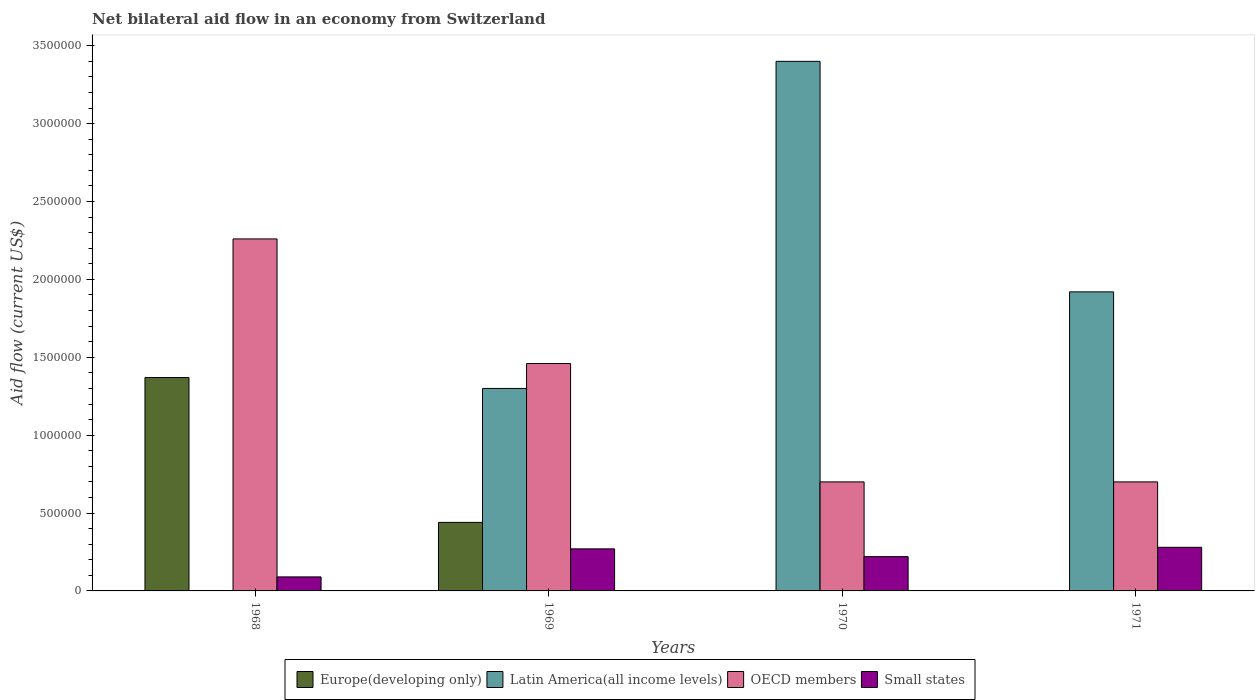How many bars are there on the 4th tick from the left?
Make the answer very short. 3. How many bars are there on the 3rd tick from the right?
Ensure brevity in your answer.  4. Across all years, what is the maximum net bilateral aid flow in Small states?
Your answer should be compact. 2.80e+05. In which year was the net bilateral aid flow in Europe(developing only) maximum?
Provide a succinct answer. 1968. What is the total net bilateral aid flow in Small states in the graph?
Your answer should be very brief. 8.60e+05. What is the difference between the net bilateral aid flow in Small states in 1969 and that in 1970?
Give a very brief answer. 5.00e+04. What is the difference between the net bilateral aid flow in OECD members in 1968 and the net bilateral aid flow in Small states in 1969?
Your answer should be compact. 1.99e+06. What is the average net bilateral aid flow in Latin America(all income levels) per year?
Your answer should be very brief. 1.66e+06. In the year 1970, what is the difference between the net bilateral aid flow in Latin America(all income levels) and net bilateral aid flow in Small states?
Offer a very short reply. 3.18e+06. What is the ratio of the net bilateral aid flow in Small states in 1968 to that in 1969?
Keep it short and to the point. 0.33. Is the difference between the net bilateral aid flow in Latin America(all income levels) in 1969 and 1971 greater than the difference between the net bilateral aid flow in Small states in 1969 and 1971?
Ensure brevity in your answer.  No. What is the difference between the highest and the second highest net bilateral aid flow in Latin America(all income levels)?
Your response must be concise. 1.48e+06. What is the difference between the highest and the lowest net bilateral aid flow in OECD members?
Your answer should be compact. 1.56e+06. Is the sum of the net bilateral aid flow in Small states in 1968 and 1969 greater than the maximum net bilateral aid flow in Europe(developing only) across all years?
Offer a very short reply. No. Is it the case that in every year, the sum of the net bilateral aid flow in OECD members and net bilateral aid flow in Latin America(all income levels) is greater than the sum of net bilateral aid flow in Small states and net bilateral aid flow in Europe(developing only)?
Make the answer very short. Yes. Is it the case that in every year, the sum of the net bilateral aid flow in Latin America(all income levels) and net bilateral aid flow in OECD members is greater than the net bilateral aid flow in Europe(developing only)?
Your response must be concise. Yes. How many years are there in the graph?
Your answer should be compact. 4. What is the difference between two consecutive major ticks on the Y-axis?
Your answer should be compact. 5.00e+05. Are the values on the major ticks of Y-axis written in scientific E-notation?
Your answer should be very brief. No. Does the graph contain any zero values?
Offer a terse response. Yes. Where does the legend appear in the graph?
Give a very brief answer. Bottom center. What is the title of the graph?
Keep it short and to the point. Net bilateral aid flow in an economy from Switzerland. Does "Upper middle income" appear as one of the legend labels in the graph?
Ensure brevity in your answer.  No. What is the label or title of the X-axis?
Offer a terse response. Years. What is the label or title of the Y-axis?
Your answer should be very brief. Aid flow (current US$). What is the Aid flow (current US$) of Europe(developing only) in 1968?
Your response must be concise. 1.37e+06. What is the Aid flow (current US$) in OECD members in 1968?
Your answer should be compact. 2.26e+06. What is the Aid flow (current US$) of Europe(developing only) in 1969?
Give a very brief answer. 4.40e+05. What is the Aid flow (current US$) of Latin America(all income levels) in 1969?
Make the answer very short. 1.30e+06. What is the Aid flow (current US$) of OECD members in 1969?
Your response must be concise. 1.46e+06. What is the Aid flow (current US$) of Europe(developing only) in 1970?
Provide a succinct answer. 0. What is the Aid flow (current US$) in Latin America(all income levels) in 1970?
Give a very brief answer. 3.40e+06. What is the Aid flow (current US$) in Small states in 1970?
Offer a very short reply. 2.20e+05. What is the Aid flow (current US$) of Latin America(all income levels) in 1971?
Your answer should be very brief. 1.92e+06. What is the Aid flow (current US$) in OECD members in 1971?
Give a very brief answer. 7.00e+05. Across all years, what is the maximum Aid flow (current US$) in Europe(developing only)?
Make the answer very short. 1.37e+06. Across all years, what is the maximum Aid flow (current US$) in Latin America(all income levels)?
Offer a very short reply. 3.40e+06. Across all years, what is the maximum Aid flow (current US$) in OECD members?
Make the answer very short. 2.26e+06. Across all years, what is the minimum Aid flow (current US$) of Latin America(all income levels)?
Your answer should be very brief. 0. Across all years, what is the minimum Aid flow (current US$) of Small states?
Your answer should be very brief. 9.00e+04. What is the total Aid flow (current US$) of Europe(developing only) in the graph?
Ensure brevity in your answer.  1.81e+06. What is the total Aid flow (current US$) in Latin America(all income levels) in the graph?
Your response must be concise. 6.62e+06. What is the total Aid flow (current US$) in OECD members in the graph?
Ensure brevity in your answer.  5.12e+06. What is the total Aid flow (current US$) in Small states in the graph?
Keep it short and to the point. 8.60e+05. What is the difference between the Aid flow (current US$) in Europe(developing only) in 1968 and that in 1969?
Provide a short and direct response. 9.30e+05. What is the difference between the Aid flow (current US$) of OECD members in 1968 and that in 1970?
Provide a short and direct response. 1.56e+06. What is the difference between the Aid flow (current US$) of OECD members in 1968 and that in 1971?
Keep it short and to the point. 1.56e+06. What is the difference between the Aid flow (current US$) of Latin America(all income levels) in 1969 and that in 1970?
Your answer should be compact. -2.10e+06. What is the difference between the Aid flow (current US$) of OECD members in 1969 and that in 1970?
Give a very brief answer. 7.60e+05. What is the difference between the Aid flow (current US$) of Latin America(all income levels) in 1969 and that in 1971?
Your answer should be very brief. -6.20e+05. What is the difference between the Aid flow (current US$) of OECD members in 1969 and that in 1971?
Offer a very short reply. 7.60e+05. What is the difference between the Aid flow (current US$) in Small states in 1969 and that in 1971?
Provide a succinct answer. -10000. What is the difference between the Aid flow (current US$) in Latin America(all income levels) in 1970 and that in 1971?
Provide a short and direct response. 1.48e+06. What is the difference between the Aid flow (current US$) of Europe(developing only) in 1968 and the Aid flow (current US$) of Latin America(all income levels) in 1969?
Offer a terse response. 7.00e+04. What is the difference between the Aid flow (current US$) in Europe(developing only) in 1968 and the Aid flow (current US$) in Small states in 1969?
Make the answer very short. 1.10e+06. What is the difference between the Aid flow (current US$) in OECD members in 1968 and the Aid flow (current US$) in Small states in 1969?
Keep it short and to the point. 1.99e+06. What is the difference between the Aid flow (current US$) in Europe(developing only) in 1968 and the Aid flow (current US$) in Latin America(all income levels) in 1970?
Your answer should be compact. -2.03e+06. What is the difference between the Aid flow (current US$) of Europe(developing only) in 1968 and the Aid flow (current US$) of OECD members in 1970?
Offer a very short reply. 6.70e+05. What is the difference between the Aid flow (current US$) of Europe(developing only) in 1968 and the Aid flow (current US$) of Small states in 1970?
Make the answer very short. 1.15e+06. What is the difference between the Aid flow (current US$) in OECD members in 1968 and the Aid flow (current US$) in Small states in 1970?
Provide a short and direct response. 2.04e+06. What is the difference between the Aid flow (current US$) in Europe(developing only) in 1968 and the Aid flow (current US$) in Latin America(all income levels) in 1971?
Offer a terse response. -5.50e+05. What is the difference between the Aid flow (current US$) of Europe(developing only) in 1968 and the Aid flow (current US$) of OECD members in 1971?
Provide a succinct answer. 6.70e+05. What is the difference between the Aid flow (current US$) of Europe(developing only) in 1968 and the Aid flow (current US$) of Small states in 1971?
Your response must be concise. 1.09e+06. What is the difference between the Aid flow (current US$) in OECD members in 1968 and the Aid flow (current US$) in Small states in 1971?
Ensure brevity in your answer.  1.98e+06. What is the difference between the Aid flow (current US$) in Europe(developing only) in 1969 and the Aid flow (current US$) in Latin America(all income levels) in 1970?
Keep it short and to the point. -2.96e+06. What is the difference between the Aid flow (current US$) of Europe(developing only) in 1969 and the Aid flow (current US$) of OECD members in 1970?
Your answer should be compact. -2.60e+05. What is the difference between the Aid flow (current US$) in Europe(developing only) in 1969 and the Aid flow (current US$) in Small states in 1970?
Offer a very short reply. 2.20e+05. What is the difference between the Aid flow (current US$) of Latin America(all income levels) in 1969 and the Aid flow (current US$) of OECD members in 1970?
Offer a very short reply. 6.00e+05. What is the difference between the Aid flow (current US$) in Latin America(all income levels) in 1969 and the Aid flow (current US$) in Small states in 1970?
Your response must be concise. 1.08e+06. What is the difference between the Aid flow (current US$) in OECD members in 1969 and the Aid flow (current US$) in Small states in 1970?
Keep it short and to the point. 1.24e+06. What is the difference between the Aid flow (current US$) in Europe(developing only) in 1969 and the Aid flow (current US$) in Latin America(all income levels) in 1971?
Your response must be concise. -1.48e+06. What is the difference between the Aid flow (current US$) in Europe(developing only) in 1969 and the Aid flow (current US$) in OECD members in 1971?
Ensure brevity in your answer.  -2.60e+05. What is the difference between the Aid flow (current US$) of Europe(developing only) in 1969 and the Aid flow (current US$) of Small states in 1971?
Your answer should be very brief. 1.60e+05. What is the difference between the Aid flow (current US$) in Latin America(all income levels) in 1969 and the Aid flow (current US$) in Small states in 1971?
Make the answer very short. 1.02e+06. What is the difference between the Aid flow (current US$) of OECD members in 1969 and the Aid flow (current US$) of Small states in 1971?
Your answer should be very brief. 1.18e+06. What is the difference between the Aid flow (current US$) of Latin America(all income levels) in 1970 and the Aid flow (current US$) of OECD members in 1971?
Give a very brief answer. 2.70e+06. What is the difference between the Aid flow (current US$) in Latin America(all income levels) in 1970 and the Aid flow (current US$) in Small states in 1971?
Give a very brief answer. 3.12e+06. What is the average Aid flow (current US$) of Europe(developing only) per year?
Offer a very short reply. 4.52e+05. What is the average Aid flow (current US$) of Latin America(all income levels) per year?
Offer a very short reply. 1.66e+06. What is the average Aid flow (current US$) of OECD members per year?
Give a very brief answer. 1.28e+06. What is the average Aid flow (current US$) in Small states per year?
Ensure brevity in your answer.  2.15e+05. In the year 1968, what is the difference between the Aid flow (current US$) in Europe(developing only) and Aid flow (current US$) in OECD members?
Provide a short and direct response. -8.90e+05. In the year 1968, what is the difference between the Aid flow (current US$) in Europe(developing only) and Aid flow (current US$) in Small states?
Your answer should be compact. 1.28e+06. In the year 1968, what is the difference between the Aid flow (current US$) of OECD members and Aid flow (current US$) of Small states?
Your response must be concise. 2.17e+06. In the year 1969, what is the difference between the Aid flow (current US$) in Europe(developing only) and Aid flow (current US$) in Latin America(all income levels)?
Keep it short and to the point. -8.60e+05. In the year 1969, what is the difference between the Aid flow (current US$) in Europe(developing only) and Aid flow (current US$) in OECD members?
Your response must be concise. -1.02e+06. In the year 1969, what is the difference between the Aid flow (current US$) of Europe(developing only) and Aid flow (current US$) of Small states?
Give a very brief answer. 1.70e+05. In the year 1969, what is the difference between the Aid flow (current US$) in Latin America(all income levels) and Aid flow (current US$) in OECD members?
Your answer should be very brief. -1.60e+05. In the year 1969, what is the difference between the Aid flow (current US$) of Latin America(all income levels) and Aid flow (current US$) of Small states?
Provide a succinct answer. 1.03e+06. In the year 1969, what is the difference between the Aid flow (current US$) in OECD members and Aid flow (current US$) in Small states?
Your answer should be compact. 1.19e+06. In the year 1970, what is the difference between the Aid flow (current US$) in Latin America(all income levels) and Aid flow (current US$) in OECD members?
Your answer should be compact. 2.70e+06. In the year 1970, what is the difference between the Aid flow (current US$) of Latin America(all income levels) and Aid flow (current US$) of Small states?
Make the answer very short. 3.18e+06. In the year 1970, what is the difference between the Aid flow (current US$) in OECD members and Aid flow (current US$) in Small states?
Provide a succinct answer. 4.80e+05. In the year 1971, what is the difference between the Aid flow (current US$) of Latin America(all income levels) and Aid flow (current US$) of OECD members?
Your answer should be very brief. 1.22e+06. In the year 1971, what is the difference between the Aid flow (current US$) in Latin America(all income levels) and Aid flow (current US$) in Small states?
Offer a very short reply. 1.64e+06. In the year 1971, what is the difference between the Aid flow (current US$) of OECD members and Aid flow (current US$) of Small states?
Give a very brief answer. 4.20e+05. What is the ratio of the Aid flow (current US$) of Europe(developing only) in 1968 to that in 1969?
Ensure brevity in your answer.  3.11. What is the ratio of the Aid flow (current US$) of OECD members in 1968 to that in 1969?
Provide a short and direct response. 1.55. What is the ratio of the Aid flow (current US$) of OECD members in 1968 to that in 1970?
Your answer should be compact. 3.23. What is the ratio of the Aid flow (current US$) of Small states in 1968 to that in 1970?
Your answer should be compact. 0.41. What is the ratio of the Aid flow (current US$) in OECD members in 1968 to that in 1971?
Your response must be concise. 3.23. What is the ratio of the Aid flow (current US$) in Small states in 1968 to that in 1971?
Provide a short and direct response. 0.32. What is the ratio of the Aid flow (current US$) in Latin America(all income levels) in 1969 to that in 1970?
Offer a very short reply. 0.38. What is the ratio of the Aid flow (current US$) in OECD members in 1969 to that in 1970?
Your answer should be compact. 2.09. What is the ratio of the Aid flow (current US$) of Small states in 1969 to that in 1970?
Provide a short and direct response. 1.23. What is the ratio of the Aid flow (current US$) of Latin America(all income levels) in 1969 to that in 1971?
Your answer should be compact. 0.68. What is the ratio of the Aid flow (current US$) in OECD members in 1969 to that in 1971?
Provide a short and direct response. 2.09. What is the ratio of the Aid flow (current US$) in Small states in 1969 to that in 1971?
Offer a very short reply. 0.96. What is the ratio of the Aid flow (current US$) in Latin America(all income levels) in 1970 to that in 1971?
Give a very brief answer. 1.77. What is the ratio of the Aid flow (current US$) in Small states in 1970 to that in 1971?
Keep it short and to the point. 0.79. What is the difference between the highest and the second highest Aid flow (current US$) of Latin America(all income levels)?
Your answer should be compact. 1.48e+06. What is the difference between the highest and the second highest Aid flow (current US$) of OECD members?
Provide a short and direct response. 8.00e+05. What is the difference between the highest and the second highest Aid flow (current US$) of Small states?
Keep it short and to the point. 10000. What is the difference between the highest and the lowest Aid flow (current US$) of Europe(developing only)?
Provide a succinct answer. 1.37e+06. What is the difference between the highest and the lowest Aid flow (current US$) of Latin America(all income levels)?
Offer a terse response. 3.40e+06. What is the difference between the highest and the lowest Aid flow (current US$) of OECD members?
Provide a short and direct response. 1.56e+06. What is the difference between the highest and the lowest Aid flow (current US$) of Small states?
Make the answer very short. 1.90e+05. 